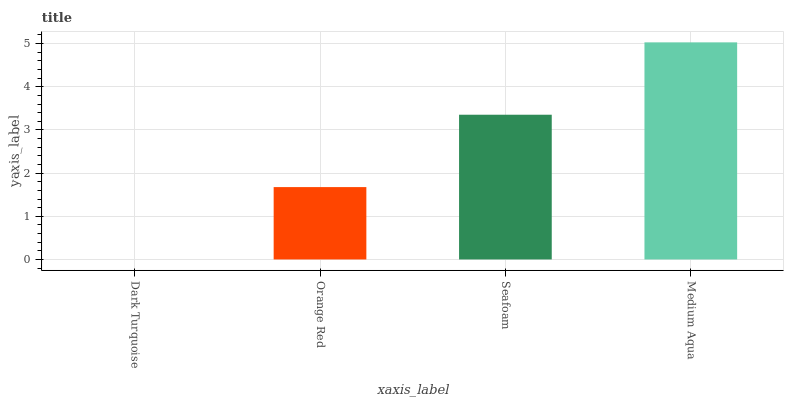Is Orange Red the minimum?
Answer yes or no. No. Is Orange Red the maximum?
Answer yes or no. No. Is Orange Red greater than Dark Turquoise?
Answer yes or no. Yes. Is Dark Turquoise less than Orange Red?
Answer yes or no. Yes. Is Dark Turquoise greater than Orange Red?
Answer yes or no. No. Is Orange Red less than Dark Turquoise?
Answer yes or no. No. Is Seafoam the high median?
Answer yes or no. Yes. Is Orange Red the low median?
Answer yes or no. Yes. Is Orange Red the high median?
Answer yes or no. No. Is Seafoam the low median?
Answer yes or no. No. 